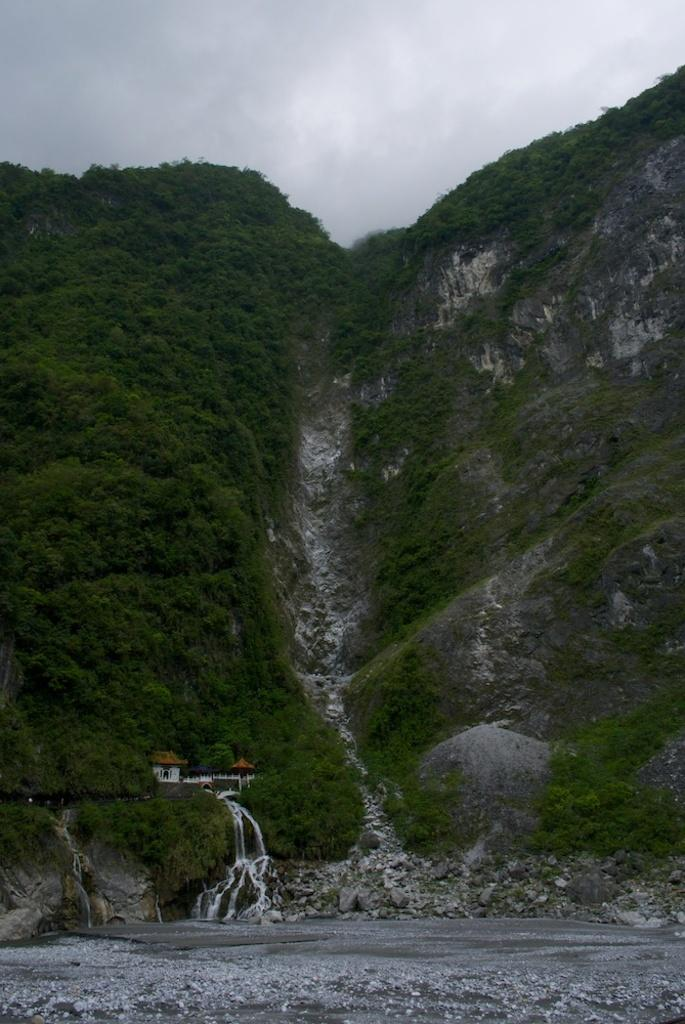What type of natural landform can be seen in the image? There are mountains in the image. What other natural elements are present in the image? There are trees and a river in the image. Are there any man-made structures visible in the image? Yes, there is a house in the image. What type of terrain is depicted in the image? There are rocks in the image, which suggests a rocky terrain. What part of the natural environment is visible in the image? The sky is visible in the image. What type of mask is the doll wearing in the image? There is no doll or mask present in the image; it features mountains, trees, rocks, a house, a river, and the sky. 